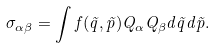Convert formula to latex. <formula><loc_0><loc_0><loc_500><loc_500>\sigma _ { \alpha \beta } = \int f ( \vec { q } , \vec { p } ) Q _ { \alpha } Q _ { \beta } d \vec { q } d \vec { p } .</formula> 